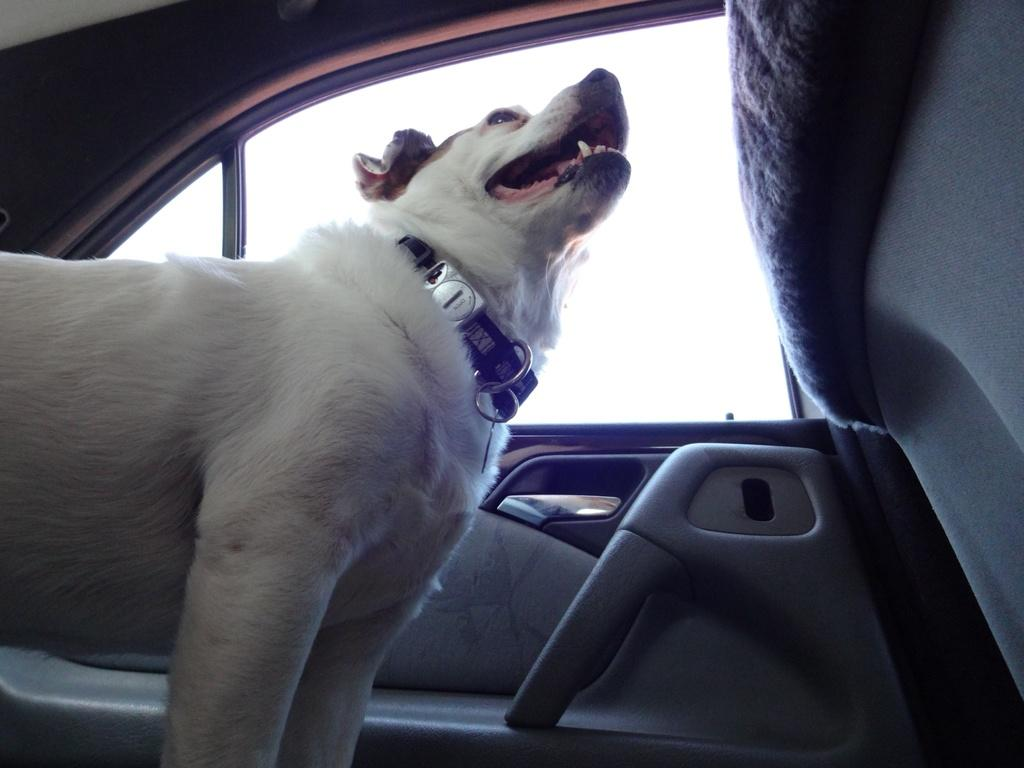What animal can be seen in the car in the image? There is a dog in the car. What part of the car is visible in the image? There is a window visible in the image. What type of furniture is visible in the image? There is no furniture present in the image. What kind of boundary can be seen around the dog in the image? There is no boundary visible around the dog in the image. 